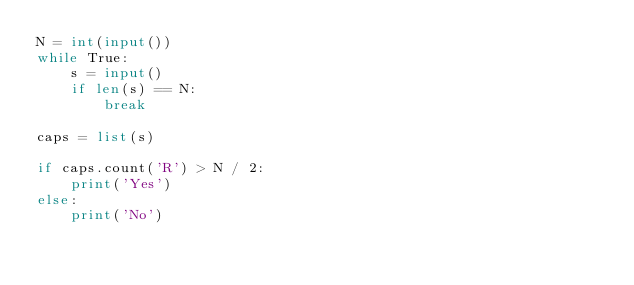<code> <loc_0><loc_0><loc_500><loc_500><_Python_>N = int(input())
while True:
    s = input()
    if len(s) == N:
        break
        
caps = list(s)

if caps.count('R') > N / 2:
    print('Yes')
else:
    print('No')
</code> 